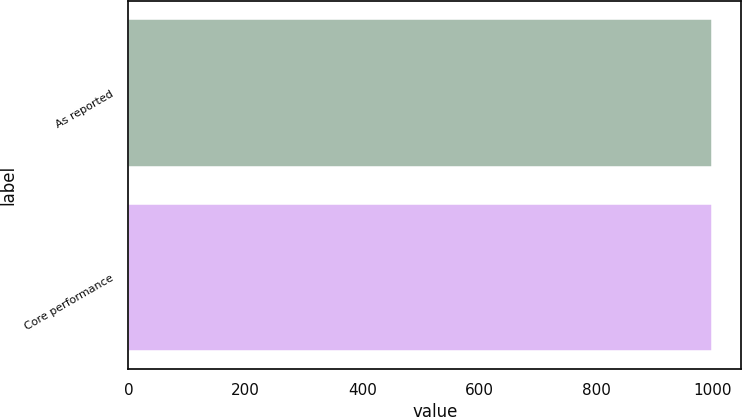<chart> <loc_0><loc_0><loc_500><loc_500><bar_chart><fcel>As reported<fcel>Core performance<nl><fcel>998<fcel>998.1<nl></chart> 